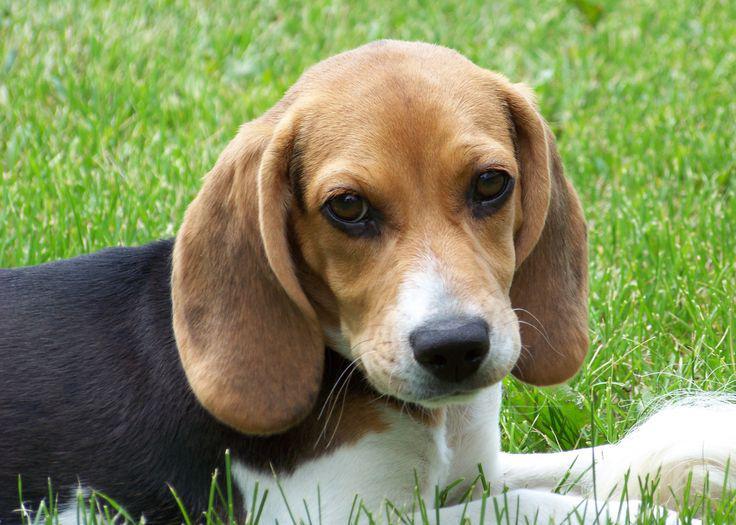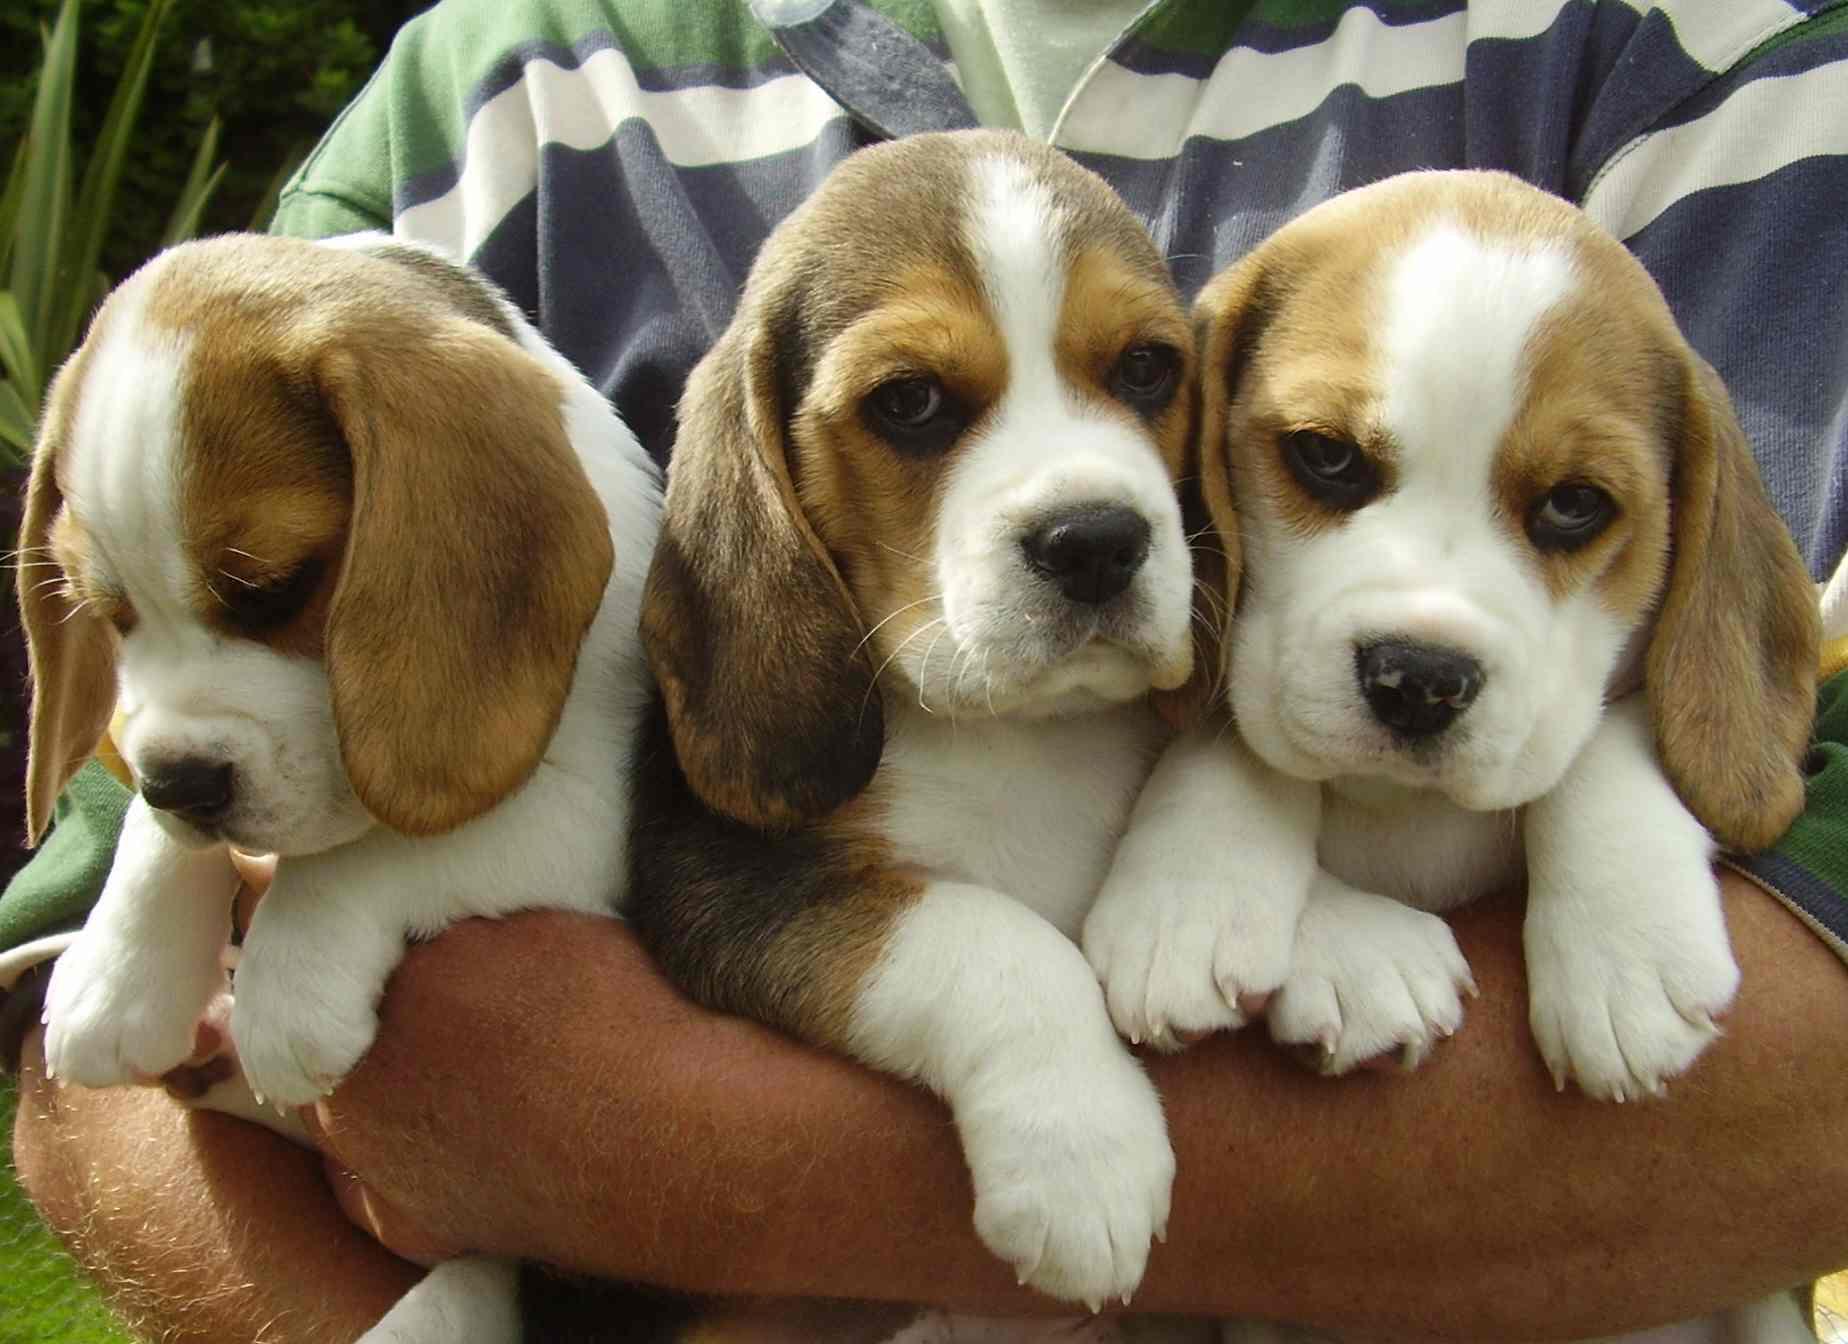The first image is the image on the left, the second image is the image on the right. For the images displayed, is the sentence "There are two beagles in each image." factually correct? Answer yes or no. No. 